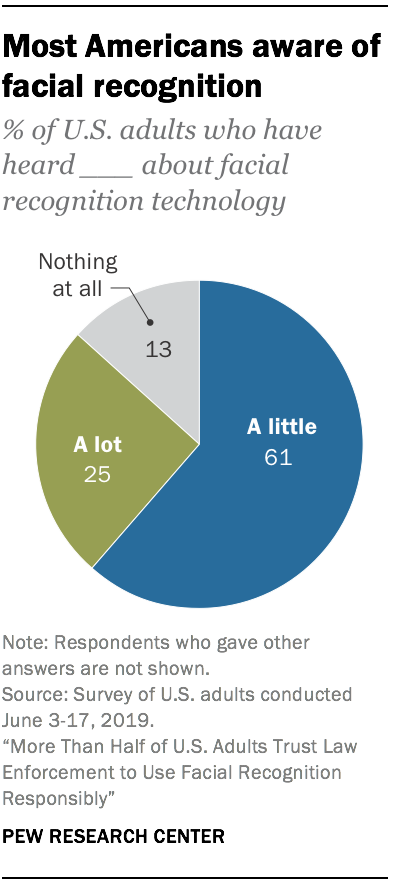Identify some key points in this picture. A recent survey found that 25% of U.S. adults have heard a lot about facial recognition technology. 